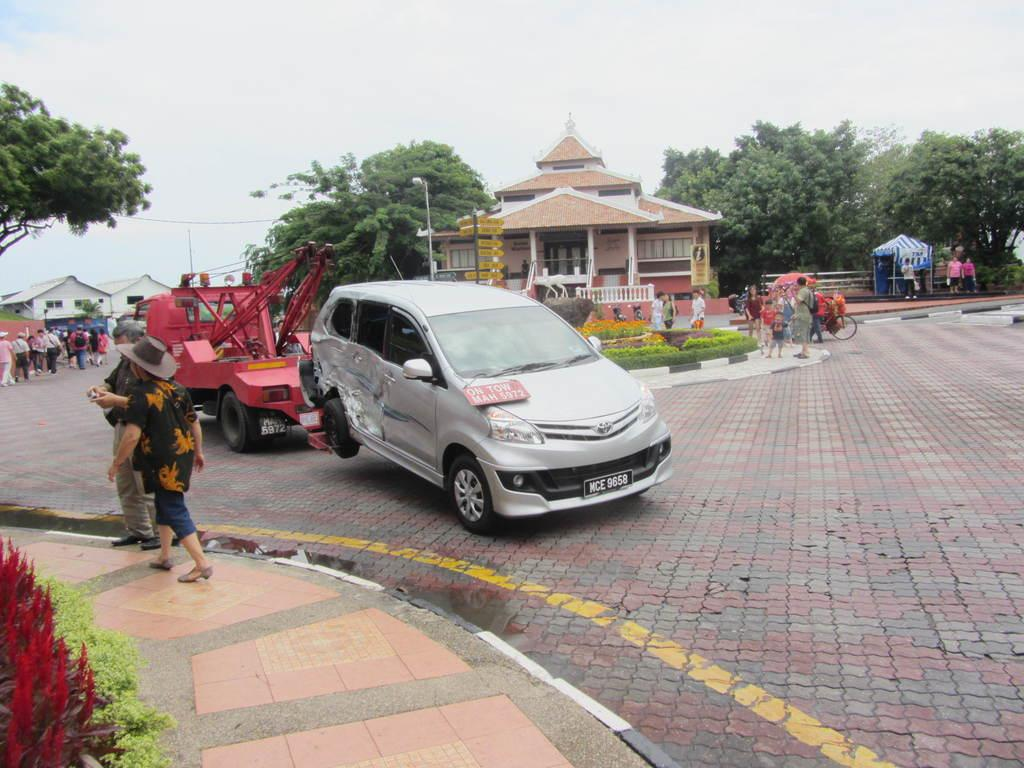How many people are in the image? There are people in the image, but the exact number is not specified. What can be seen on the road in the image? There are vehicles on the road in the image. What type of vegetation is present in the image? There are trees in the image. What type of structures can be seen in the image? There are buildings in the image. What type of signage is present in the image? There are sign boards in the image. What type of lighting is visible in the image? There is light visible in the image. What type of barrier is present in the image? There is a fence in the image. What type of temporary shelter is present in the image? There is a tent in the image. What can be seen in the background of the image? The sky is visible in the background of the image. Can you tell me how many judges are playing chess in the image? There is no mention of judges or chess in the image; it features people, vehicles, trees, buildings, sign boards, light, a fence, a tent, and the sky. What is the starting position of the chess game in the image? There is no chess game present in the image. 